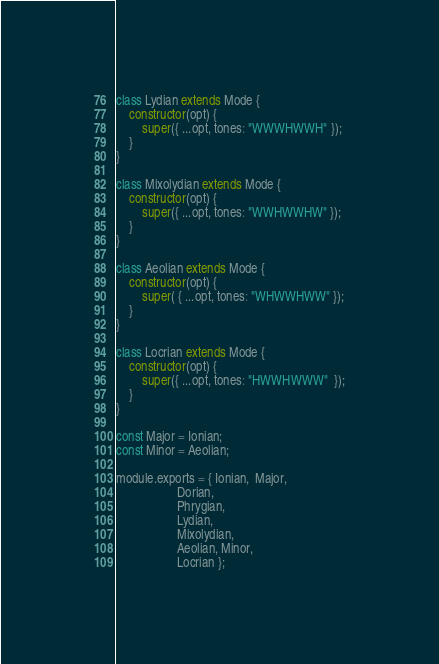<code> <loc_0><loc_0><loc_500><loc_500><_JavaScript_>class Lydian extends Mode {
    constructor(opt) {
        super({ ...opt, tones: "WWWHWWH" });
    }
}

class Mixolydian extends Mode {
    constructor(opt) {
        super({ ...opt, tones: "WWHWWHW" });
    }
}

class Aeolian extends Mode {
    constructor(opt) {
        super( { ...opt, tones: "WHWWHWW" });
    }
}

class Locrian extends Mode {
    constructor(opt) {
        super({ ...opt, tones: "HWWHWWW"  });
    }
}

const Major = Ionian;
const Minor = Aeolian;

module.exports = { Ionian,  Major,
                   Dorian,
                   Phrygian,
                   Lydian,
                   Mixolydian,
                   Aeolian, Minor,
                   Locrian };
</code> 